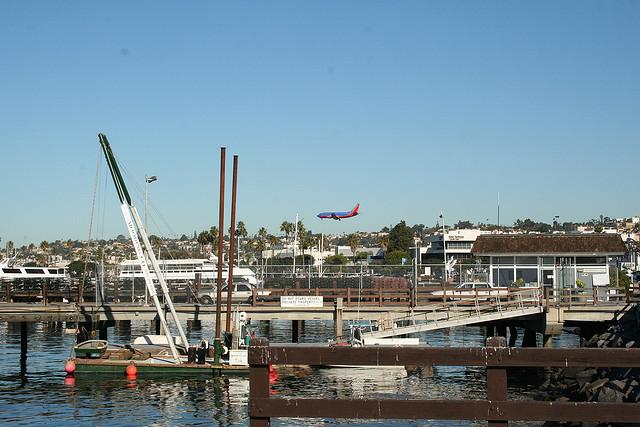What is soaring through the air? Please explain your reasoning. airplane. There is only one object visible in the air and it is clearly answer a based on the size and shape and its location in the sky. 